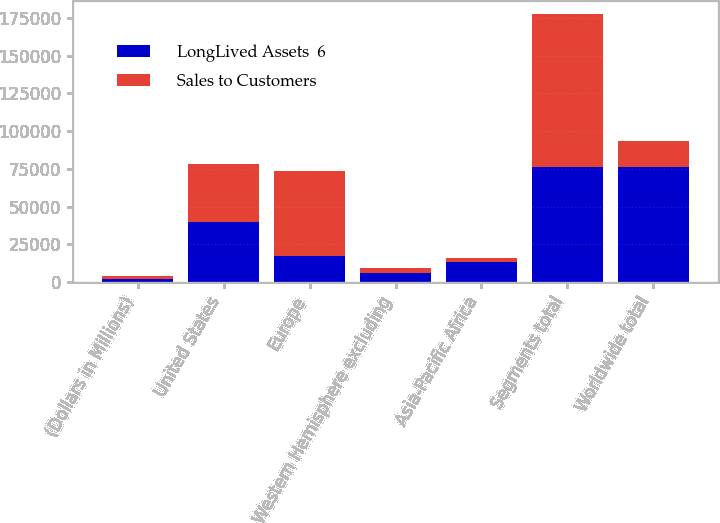Convert chart. <chart><loc_0><loc_0><loc_500><loc_500><stacked_bar_chart><ecel><fcel>(Dollars in Millions)<fcel>United States<fcel>Europe<fcel>Western Hemisphere excluding<fcel>Asia-Pacific Africa<fcel>Segments total<fcel>Worldwide total<nl><fcel>LongLived Assets  6<fcel>2017<fcel>39863<fcel>17126<fcel>6041<fcel>13420<fcel>76450<fcel>76450<nl><fcel>Sales to Customers<fcel>2017<fcel>38556<fcel>56677<fcel>2990<fcel>2773<fcel>100996<fcel>17126<nl></chart> 